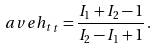<formula> <loc_0><loc_0><loc_500><loc_500>\ a v e { h _ { t } } _ { t } = \frac { I _ { 1 } + I _ { 2 } - 1 } { I _ { 2 } - I _ { 1 } + 1 } \, .</formula> 